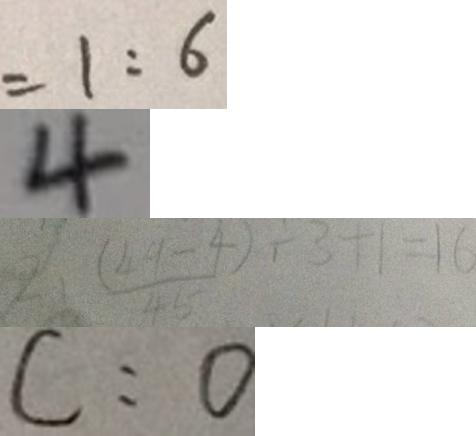<formula> <loc_0><loc_0><loc_500><loc_500>= 1 : 6 
 4 
 2 . \frac { ( 4 9 - 4 ) } { 4 5 } \div 3 + 1 = 1 6 
 C : 0</formula> 